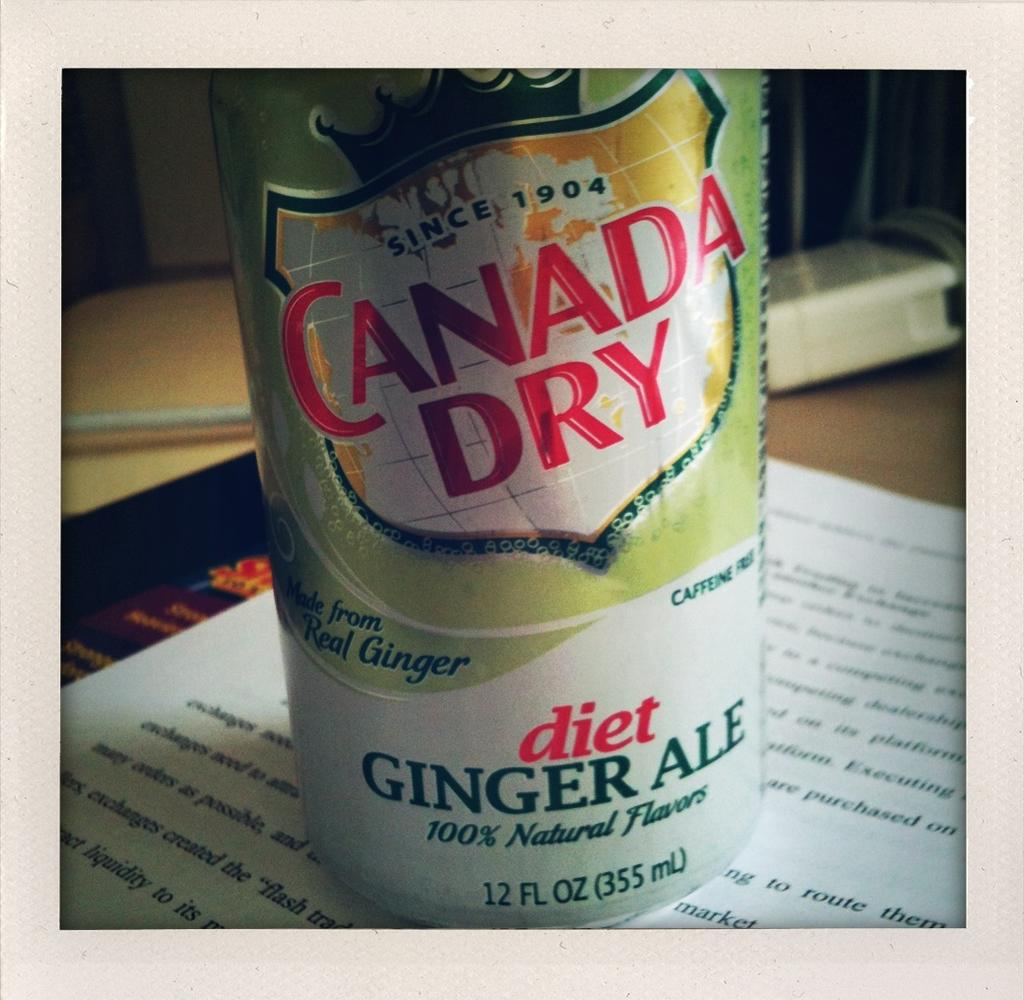Provide a one-sentence caption for the provided image. A can of diet Ginger Ale from Canada Dry on top of an open book. 